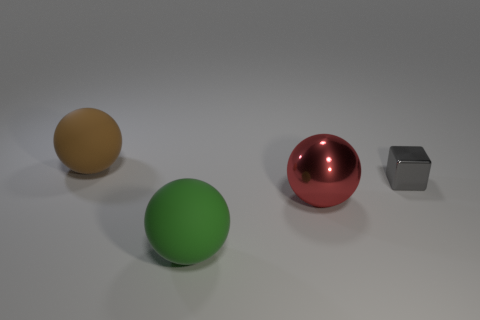What shape is the big green thing?
Offer a very short reply. Sphere. Is the big metal thing the same color as the small metal thing?
Your answer should be very brief. No. How many things are either tiny blocks behind the large red metallic object or small blue matte spheres?
Offer a terse response. 1. The gray thing that is made of the same material as the red ball is what size?
Your response must be concise. Small. Are there more metal objects that are in front of the big shiny ball than red things?
Your answer should be very brief. No. Does the tiny gray object have the same shape as the big rubber object behind the gray block?
Give a very brief answer. No. How many tiny objects are either metal objects or green matte things?
Your answer should be compact. 1. The rubber thing to the right of the thing that is behind the gray thing is what color?
Make the answer very short. Green. Does the green object have the same material as the object that is to the left of the green object?
Keep it short and to the point. Yes. There is a large green ball in front of the gray metal cube; what is it made of?
Ensure brevity in your answer.  Rubber. 